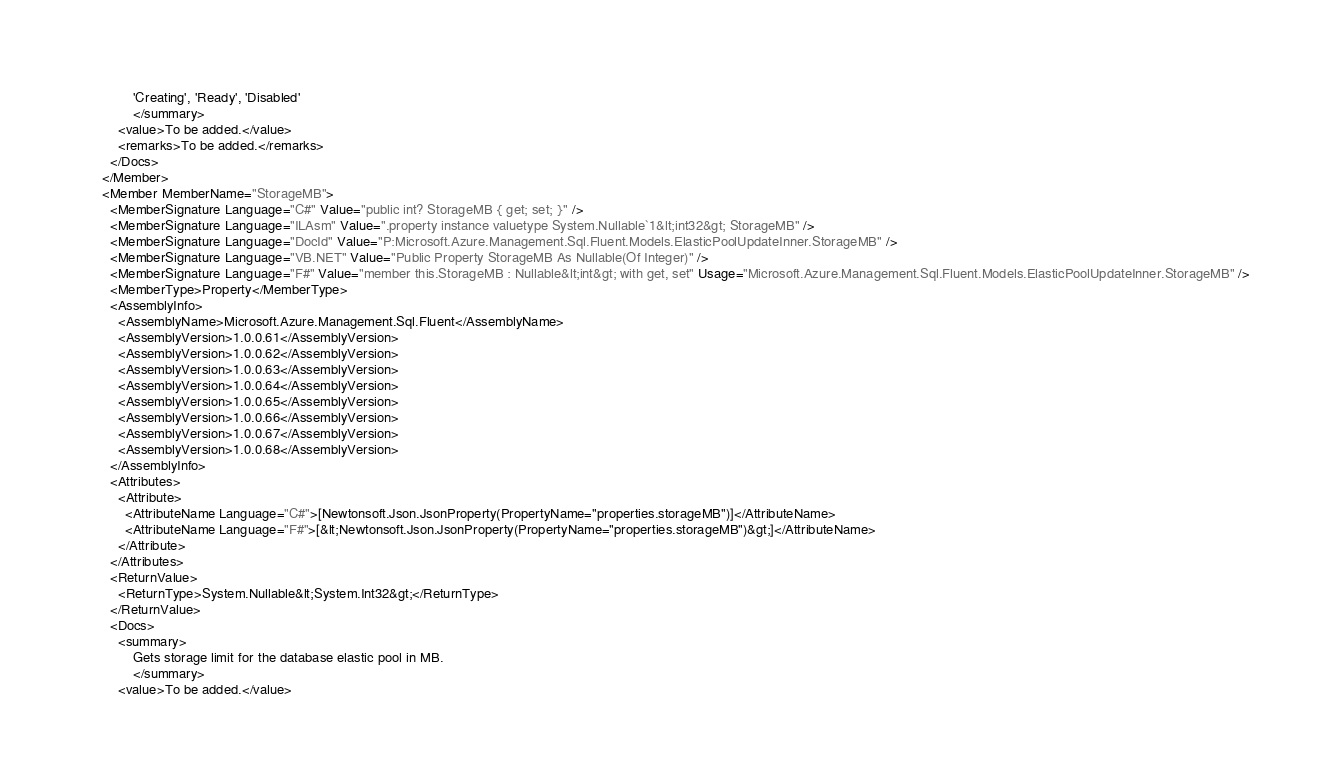<code> <loc_0><loc_0><loc_500><loc_500><_XML_>            'Creating', 'Ready', 'Disabled'
            </summary>
        <value>To be added.</value>
        <remarks>To be added.</remarks>
      </Docs>
    </Member>
    <Member MemberName="StorageMB">
      <MemberSignature Language="C#" Value="public int? StorageMB { get; set; }" />
      <MemberSignature Language="ILAsm" Value=".property instance valuetype System.Nullable`1&lt;int32&gt; StorageMB" />
      <MemberSignature Language="DocId" Value="P:Microsoft.Azure.Management.Sql.Fluent.Models.ElasticPoolUpdateInner.StorageMB" />
      <MemberSignature Language="VB.NET" Value="Public Property StorageMB As Nullable(Of Integer)" />
      <MemberSignature Language="F#" Value="member this.StorageMB : Nullable&lt;int&gt; with get, set" Usage="Microsoft.Azure.Management.Sql.Fluent.Models.ElasticPoolUpdateInner.StorageMB" />
      <MemberType>Property</MemberType>
      <AssemblyInfo>
        <AssemblyName>Microsoft.Azure.Management.Sql.Fluent</AssemblyName>
        <AssemblyVersion>1.0.0.61</AssemblyVersion>
        <AssemblyVersion>1.0.0.62</AssemblyVersion>
        <AssemblyVersion>1.0.0.63</AssemblyVersion>
        <AssemblyVersion>1.0.0.64</AssemblyVersion>
        <AssemblyVersion>1.0.0.65</AssemblyVersion>
        <AssemblyVersion>1.0.0.66</AssemblyVersion>
        <AssemblyVersion>1.0.0.67</AssemblyVersion>
        <AssemblyVersion>1.0.0.68</AssemblyVersion>
      </AssemblyInfo>
      <Attributes>
        <Attribute>
          <AttributeName Language="C#">[Newtonsoft.Json.JsonProperty(PropertyName="properties.storageMB")]</AttributeName>
          <AttributeName Language="F#">[&lt;Newtonsoft.Json.JsonProperty(PropertyName="properties.storageMB")&gt;]</AttributeName>
        </Attribute>
      </Attributes>
      <ReturnValue>
        <ReturnType>System.Nullable&lt;System.Int32&gt;</ReturnType>
      </ReturnValue>
      <Docs>
        <summary>
            Gets storage limit for the database elastic pool in MB.
            </summary>
        <value>To be added.</value></code> 